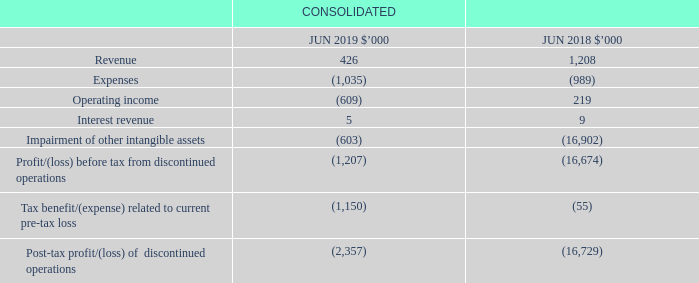6.3 Changes in group structure
Discontinued operations
On 21 December 2018, the Group executed a share sale agreement to sell Infochoice Pty Ltd, a wholly owned subsidiary.
At 30 June 2019, Infochoice Pty Ltd was classified as a discontinued operation. The business of Infochoice Pty Ltd represented the Group’s financial services and products comparison operating segment. With Infochoice Pty Ltd being classified as a discontinued operation, its operating results are no longer presented in the segment note. The sale of Infochoice Pty Ltd was completed on 18 February 2019. The results of Infochoice Pty Ltd for the period are presented below:
When was  Infochoice Pty Ltd classified as a discontinued operation? 30 june 2019. What did the business of Infochoice Pty Ltd represent? The group’s financial services and products comparison operating segment. What is the Post-tax loss of  discontinued operations in 2019?
Answer scale should be: thousand. 2,357. What is the percentage change in the revenue from 2018 to 2019?
Answer scale should be: percent. (426-1,208)/1,208
Answer: -64.74. What is the percentage change in the interest revenue from 2018 to 2019?
Answer scale should be: percent. (5-9)/9
Answer: -44.44. In which year is there a higher revenue? Find the year with the higher revenue
Answer: 2018. 